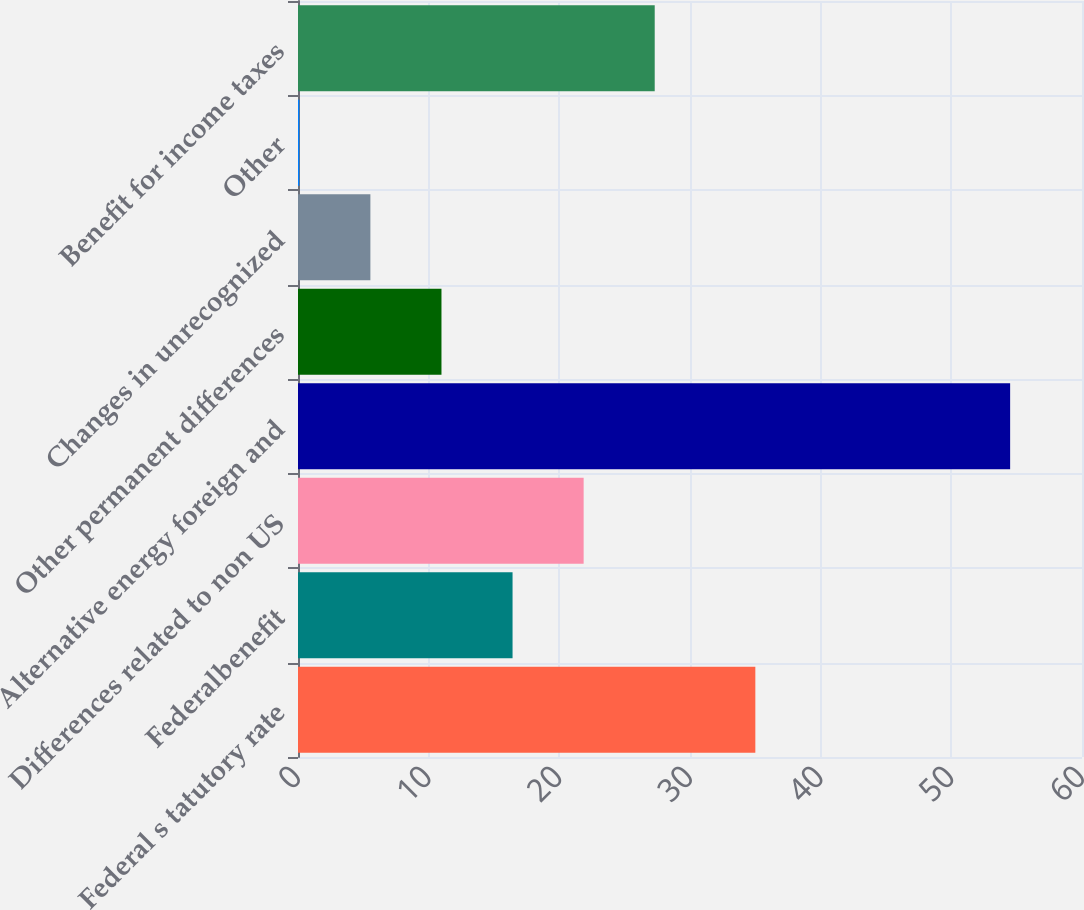Convert chart to OTSL. <chart><loc_0><loc_0><loc_500><loc_500><bar_chart><fcel>Federal s tatutory rate<fcel>Federalbenefit<fcel>Differences related to non US<fcel>Alternative energy foreign and<fcel>Other permanent differences<fcel>Changes in unrecognized<fcel>Other<fcel>Benefit for income taxes<nl><fcel>35<fcel>16.42<fcel>21.86<fcel>54.5<fcel>10.98<fcel>5.54<fcel>0.1<fcel>27.3<nl></chart> 